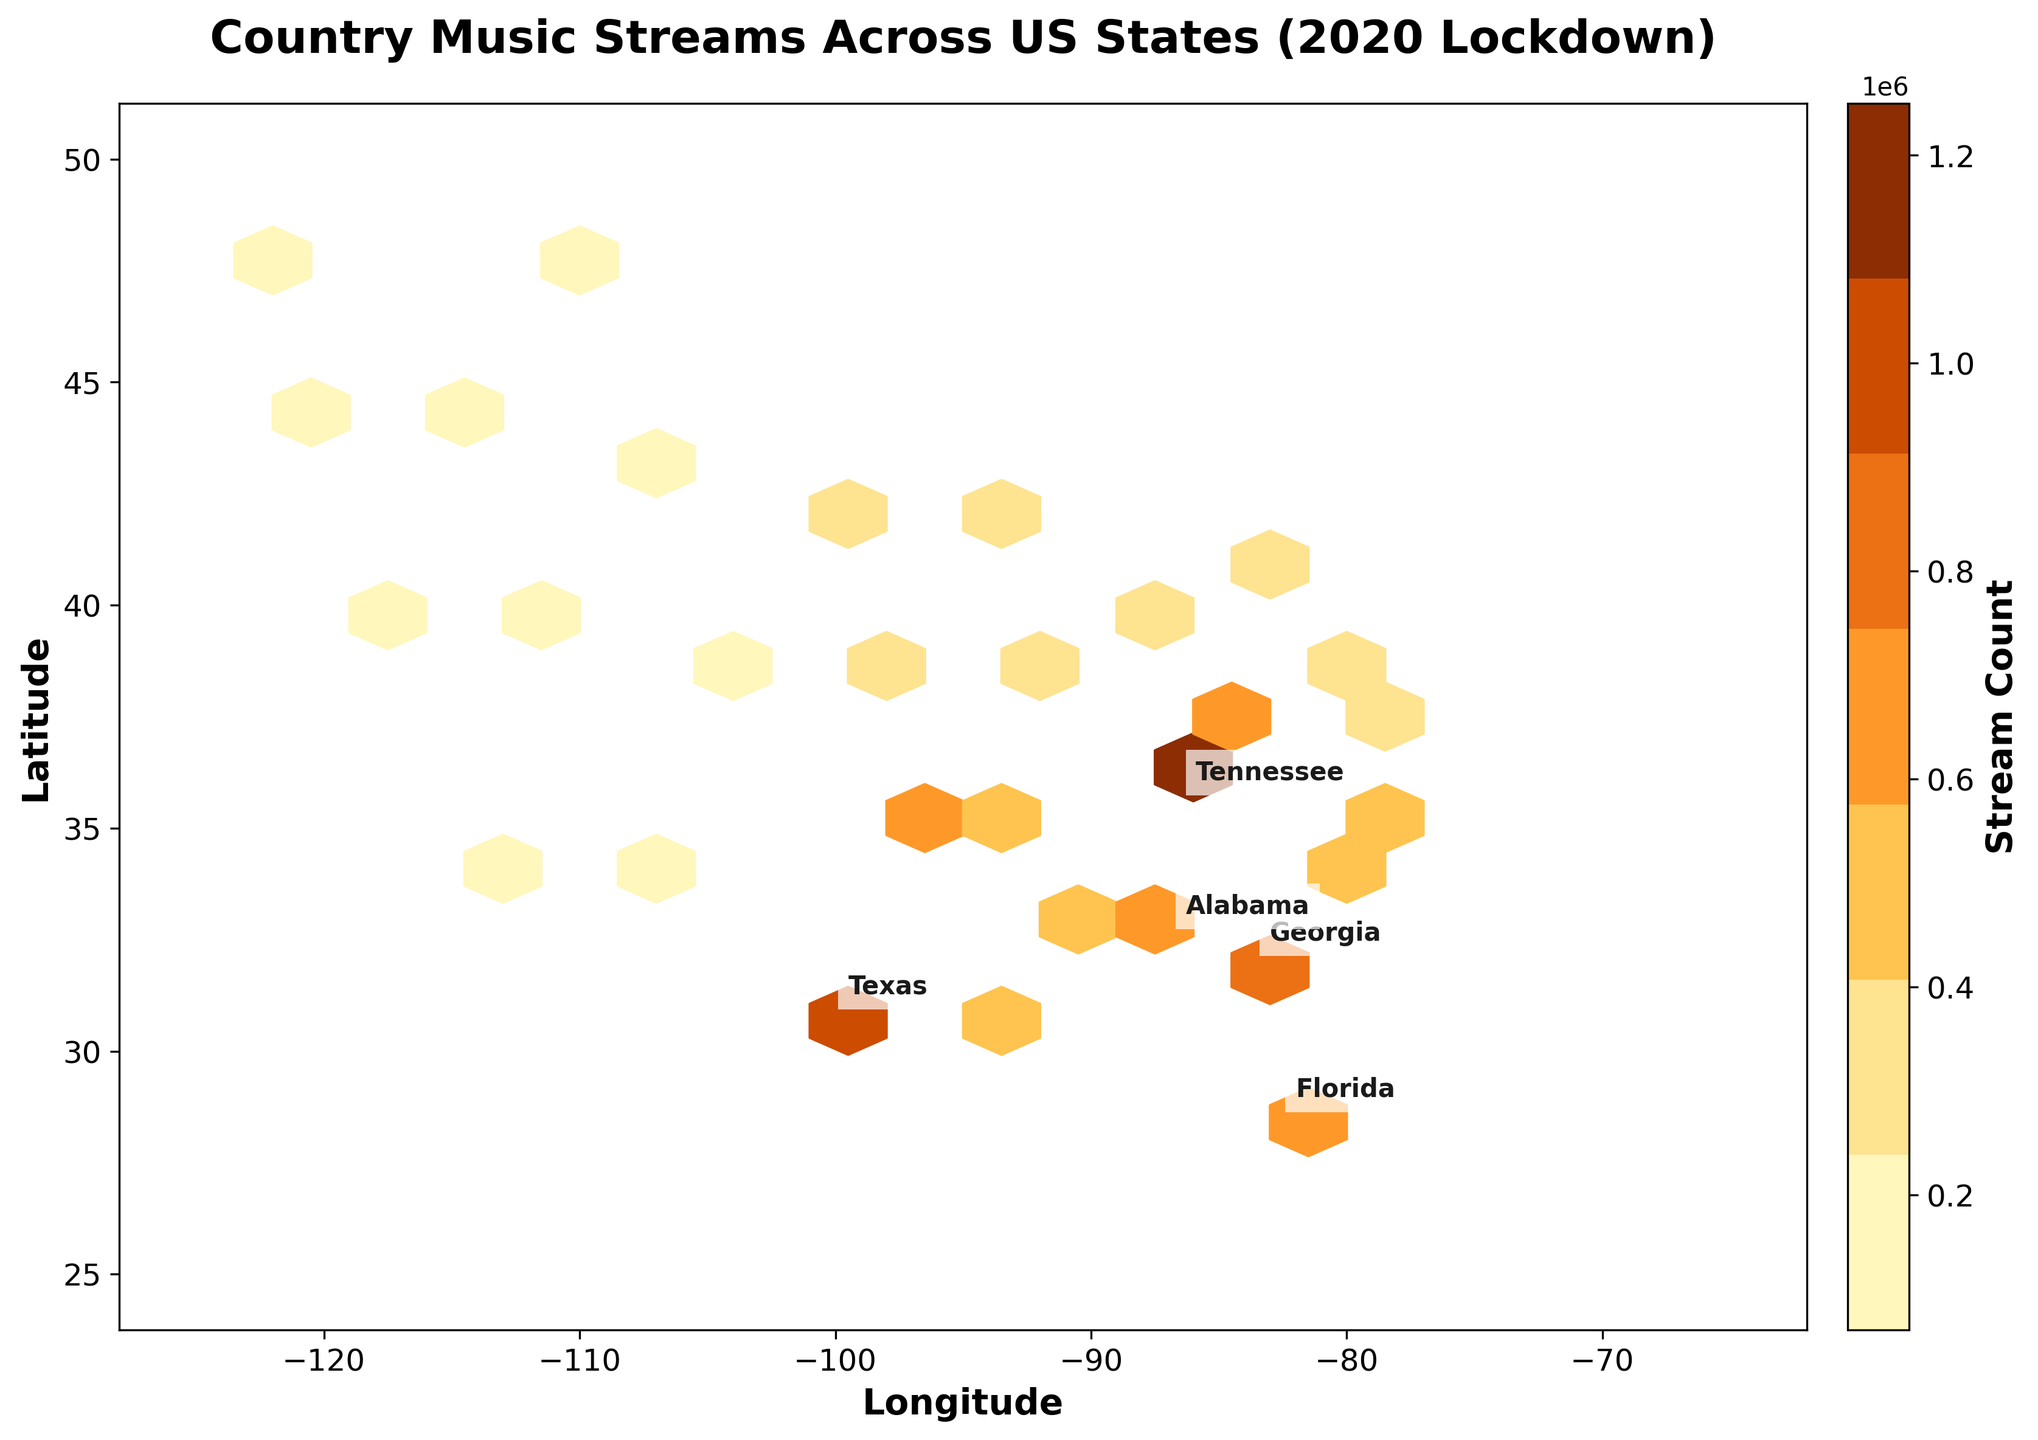What is the title of the hexbin plot? The title is usually placed at the top of the figure, in this plot it reads 'Country Music Streams Across US States (2020 Lockdown)'.
Answer: Country Music Streams Across US States (2020 Lockdown) What does the color scale in the plot represent? The color scale usually indicates the quantity or intensity of a variable. In this case, it represents the 'Stream Count' of country music in different states.
Answer: Stream Count How many states are labeled on the plot? The plot labels the top 5 states with the highest stream counts. Look for annotations near the hexagons containing state names.
Answer: 5 Which state had the highest stream count of country music streams during the lockdown? The topmost hexagon among those labeled will likely have the highest stream count. Based on the data, Tennessee is the most labeled state.
Answer: Tennessee What is the stream count color range on the colorbar? The colorbar gives the range of values used in the plot. It typically shows from the lowest to the highest stream counts. In this plot, it ranges from '70000' to '1250000'.
Answer: 70000 to 1250000 Which state has the second highest stream count? The state labeled just below or near Tennessee with a slightly lower count will be the second highest. According to the data, this is Texas.
Answer: Texas How does the stream count in Georgia compare to that in Florida? Identify the colors representing Georgia and Florida on the plot and check which is darker. Darker indicates a higher stream count. The plot and data show Georgia having a higher stream count than Florida.
Answer: Higher in Georgia What is the approximate latitude and longitude where the highest density of streams is found? Examine the plot for the densest cluster of hexagons with the darkest colors. Check where it is located. According to the data, Tennessee is around latitude 35.8 and longitude -86.4.
Answer: Latitude 35.8, Longitude -86.4 Walk through the steps to find the total stream count for the top 5 states. First, identify the top 5 states (Tennessee, Texas, Georgia, Florida, Alabama) from the plot or data. Then sum their stream counts: 1250000 + 980000 + 850000 + 720000 + 680000.
Answer: 4480000 Explain how the distribution of streams changes geographically across the US. Observe the concentration and color intensity of hexagons from east to west. The Eastern and Southeastern regions (e.g., Tennessee, Texas) have more streams and darker hexagons, while the Western regions have fewer streams and lighter hexagons.
Answer: More concentrated in the East/Southeast 